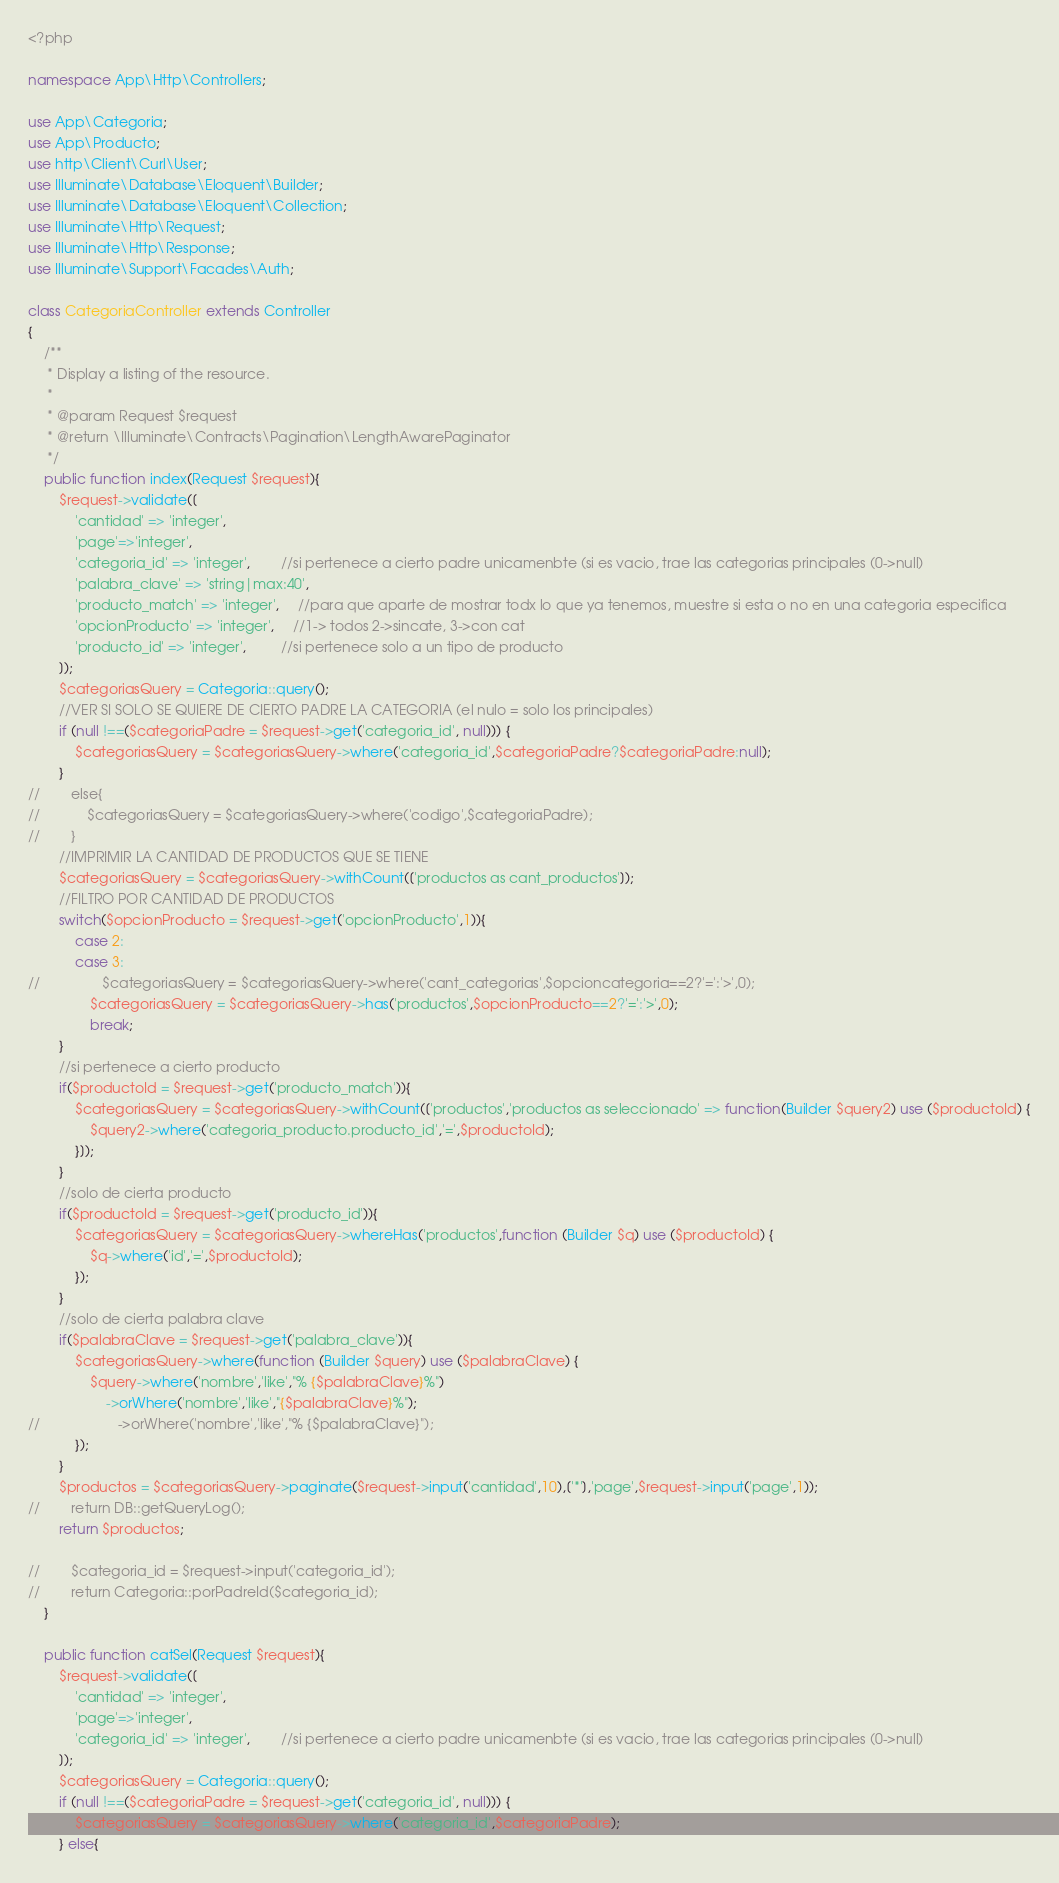<code> <loc_0><loc_0><loc_500><loc_500><_PHP_><?php

namespace App\Http\Controllers;

use App\Categoria;
use App\Producto;
use http\Client\Curl\User;
use Illuminate\Database\Eloquent\Builder;
use Illuminate\Database\Eloquent\Collection;
use Illuminate\Http\Request;
use Illuminate\Http\Response;
use Illuminate\Support\Facades\Auth;

class CategoriaController extends Controller
{
    /**
     * Display a listing of the resource.
     *
     * @param Request $request
     * @return \Illuminate\Contracts\Pagination\LengthAwarePaginator
     */
    public function index(Request $request){
        $request->validate([
            'cantidad' => 'integer',
            'page'=>'integer',
            'categoria_id' => 'integer',        //si pertenece a cierto padre unicamenbte (si es vacio, trae las categorias principales (0->null)
            'palabra_clave' => 'string|max:40',
            'producto_match' => 'integer',     //para que aparte de mostrar todx lo que ya tenemos, muestre si esta o no en una categoria especifica
            'opcionProducto' => 'integer',     //1-> todos 2->sincate, 3->con cat
            'producto_id' => 'integer',         //si pertenece solo a un tipo de producto
        ]);
        $categoriasQuery = Categoria::query();
        //VER SI SOLO SE QUIERE DE CIERTO PADRE LA CATEGORIA (el nulo = solo los principales)
        if (null !==($categoriaPadre = $request->get('categoria_id', null))) {
            $categoriasQuery = $categoriasQuery->where('categoria_id',$categoriaPadre?$categoriaPadre:null);
        }
//        else{
//            $categoriasQuery = $categoriasQuery->where('codigo',$categoriaPadre);
//        }
        //IMPRIMIR LA CANTIDAD DE PRODUCTOS QUE SE TIENE
        $categoriasQuery = $categoriasQuery->withCount(['productos as cant_productos']);
        //FILTRO POR CANTIDAD DE PRODUCTOS
        switch($opcionProducto = $request->get('opcionProducto',1)){
            case 2:
            case 3:
//                $categoriasQuery = $categoriasQuery->where('cant_categorias',$opcioncategoria==2?'=':'>',0);
                $categoriasQuery = $categoriasQuery->has('productos',$opcionProducto==2?'=':'>',0);
                break;
        }
        //si pertenece a cierto producto
        if($productoId = $request->get('producto_match')){
            $categoriasQuery = $categoriasQuery->withCount(['productos','productos as seleccionado' => function(Builder $query2) use ($productoId) {
                $query2->where('categoria_producto.producto_id','=',$productoId);
            }]);
        }
        //solo de cierta producto
        if($productoId = $request->get('producto_id')){
            $categoriasQuery = $categoriasQuery->whereHas('productos',function (Builder $q) use ($productoId) {
                $q->where('id','=',$productoId);
            });
        }
        //solo de cierta palabra clave
        if($palabraClave = $request->get('palabra_clave')){
            $categoriasQuery->where(function (Builder $query) use ($palabraClave) {
                $query->where('nombre','like',"% {$palabraClave}%")
                    ->orWhere('nombre','like',"{$palabraClave}%");
//                    ->orWhere('nombre','like',"% {$palabraClave}");
            });
        }
        $productos = $categoriasQuery->paginate($request->input('cantidad',10),['*'],'page',$request->input('page',1));
//        return DB::getQueryLog();
        return $productos;

//        $categoria_id = $request->input('categoria_id');
//        return Categoria::porPadreId($categoria_id);
    }

    public function catSel(Request $request){
        $request->validate([
            'cantidad' => 'integer',
            'page'=>'integer',
            'categoria_id' => 'integer',        //si pertenece a cierto padre unicamenbte (si es vacio, trae las categorias principales (0->null)
        ]);
        $categoriasQuery = Categoria::query();
        if (null !==($categoriaPadre = $request->get('categoria_id', null))) {
            $categoriasQuery = $categoriasQuery->where('categoria_id',$categoriaPadre);
        } else{</code> 